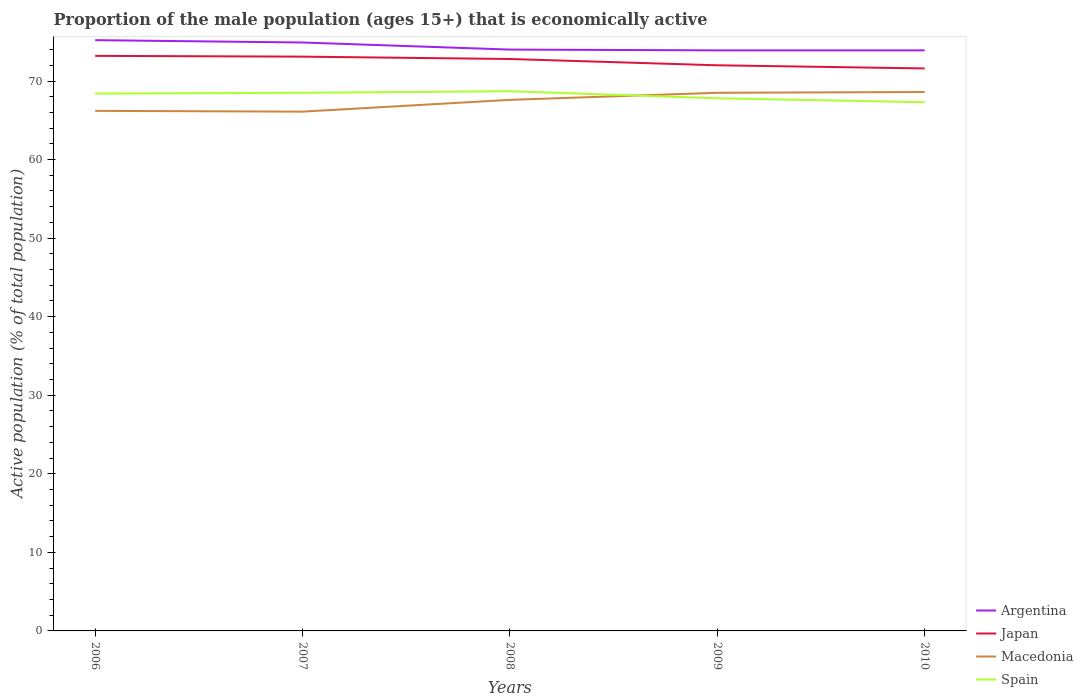Does the line corresponding to Macedonia intersect with the line corresponding to Argentina?
Offer a very short reply. No. Is the number of lines equal to the number of legend labels?
Keep it short and to the point. Yes. Across all years, what is the maximum proportion of the male population that is economically active in Argentina?
Provide a short and direct response. 73.9. In which year was the proportion of the male population that is economically active in Japan maximum?
Provide a succinct answer. 2010. What is the total proportion of the male population that is economically active in Japan in the graph?
Your response must be concise. 0.8. What is the difference between the highest and the second highest proportion of the male population that is economically active in Argentina?
Offer a terse response. 1.3. What is the difference between the highest and the lowest proportion of the male population that is economically active in Spain?
Make the answer very short. 3. How many years are there in the graph?
Provide a succinct answer. 5. Does the graph contain any zero values?
Give a very brief answer. No. What is the title of the graph?
Offer a terse response. Proportion of the male population (ages 15+) that is economically active. Does "Cote d'Ivoire" appear as one of the legend labels in the graph?
Your answer should be very brief. No. What is the label or title of the Y-axis?
Your response must be concise. Active population (% of total population). What is the Active population (% of total population) in Argentina in 2006?
Give a very brief answer. 75.2. What is the Active population (% of total population) of Japan in 2006?
Your response must be concise. 73.2. What is the Active population (% of total population) of Macedonia in 2006?
Offer a very short reply. 66.2. What is the Active population (% of total population) of Spain in 2006?
Your response must be concise. 68.4. What is the Active population (% of total population) of Argentina in 2007?
Ensure brevity in your answer.  74.9. What is the Active population (% of total population) of Japan in 2007?
Ensure brevity in your answer.  73.1. What is the Active population (% of total population) in Macedonia in 2007?
Ensure brevity in your answer.  66.1. What is the Active population (% of total population) of Spain in 2007?
Keep it short and to the point. 68.5. What is the Active population (% of total population) of Japan in 2008?
Provide a succinct answer. 72.8. What is the Active population (% of total population) of Macedonia in 2008?
Keep it short and to the point. 67.6. What is the Active population (% of total population) of Spain in 2008?
Keep it short and to the point. 68.7. What is the Active population (% of total population) in Argentina in 2009?
Give a very brief answer. 73.9. What is the Active population (% of total population) in Macedonia in 2009?
Your answer should be compact. 68.5. What is the Active population (% of total population) of Spain in 2009?
Offer a terse response. 67.8. What is the Active population (% of total population) of Argentina in 2010?
Provide a short and direct response. 73.9. What is the Active population (% of total population) of Japan in 2010?
Your answer should be compact. 71.6. What is the Active population (% of total population) of Macedonia in 2010?
Provide a short and direct response. 68.6. What is the Active population (% of total population) in Spain in 2010?
Keep it short and to the point. 67.3. Across all years, what is the maximum Active population (% of total population) of Argentina?
Provide a succinct answer. 75.2. Across all years, what is the maximum Active population (% of total population) of Japan?
Offer a very short reply. 73.2. Across all years, what is the maximum Active population (% of total population) in Macedonia?
Offer a terse response. 68.6. Across all years, what is the maximum Active population (% of total population) of Spain?
Your answer should be compact. 68.7. Across all years, what is the minimum Active population (% of total population) in Argentina?
Provide a short and direct response. 73.9. Across all years, what is the minimum Active population (% of total population) of Japan?
Your answer should be compact. 71.6. Across all years, what is the minimum Active population (% of total population) in Macedonia?
Provide a succinct answer. 66.1. Across all years, what is the minimum Active population (% of total population) in Spain?
Provide a short and direct response. 67.3. What is the total Active population (% of total population) of Argentina in the graph?
Offer a terse response. 371.9. What is the total Active population (% of total population) of Japan in the graph?
Provide a short and direct response. 362.7. What is the total Active population (% of total population) in Macedonia in the graph?
Give a very brief answer. 337. What is the total Active population (% of total population) of Spain in the graph?
Make the answer very short. 340.7. What is the difference between the Active population (% of total population) of Argentina in 2006 and that in 2007?
Ensure brevity in your answer.  0.3. What is the difference between the Active population (% of total population) of Macedonia in 2006 and that in 2007?
Provide a short and direct response. 0.1. What is the difference between the Active population (% of total population) of Spain in 2006 and that in 2007?
Offer a terse response. -0.1. What is the difference between the Active population (% of total population) of Argentina in 2006 and that in 2008?
Keep it short and to the point. 1.2. What is the difference between the Active population (% of total population) in Japan in 2006 and that in 2008?
Provide a succinct answer. 0.4. What is the difference between the Active population (% of total population) in Macedonia in 2006 and that in 2008?
Keep it short and to the point. -1.4. What is the difference between the Active population (% of total population) in Japan in 2006 and that in 2009?
Provide a succinct answer. 1.2. What is the difference between the Active population (% of total population) of Argentina in 2006 and that in 2010?
Your answer should be very brief. 1.3. What is the difference between the Active population (% of total population) of Macedonia in 2006 and that in 2010?
Provide a short and direct response. -2.4. What is the difference between the Active population (% of total population) in Argentina in 2007 and that in 2008?
Your answer should be very brief. 0.9. What is the difference between the Active population (% of total population) of Macedonia in 2007 and that in 2008?
Your answer should be very brief. -1.5. What is the difference between the Active population (% of total population) of Spain in 2007 and that in 2008?
Ensure brevity in your answer.  -0.2. What is the difference between the Active population (% of total population) of Japan in 2007 and that in 2009?
Keep it short and to the point. 1.1. What is the difference between the Active population (% of total population) of Spain in 2007 and that in 2009?
Offer a very short reply. 0.7. What is the difference between the Active population (% of total population) in Argentina in 2007 and that in 2010?
Offer a very short reply. 1. What is the difference between the Active population (% of total population) of Macedonia in 2007 and that in 2010?
Offer a terse response. -2.5. What is the difference between the Active population (% of total population) of Spain in 2007 and that in 2010?
Make the answer very short. 1.2. What is the difference between the Active population (% of total population) in Spain in 2008 and that in 2009?
Provide a succinct answer. 0.9. What is the difference between the Active population (% of total population) in Argentina in 2008 and that in 2010?
Provide a succinct answer. 0.1. What is the difference between the Active population (% of total population) of Japan in 2008 and that in 2010?
Offer a terse response. 1.2. What is the difference between the Active population (% of total population) in Macedonia in 2008 and that in 2010?
Give a very brief answer. -1. What is the difference between the Active population (% of total population) of Spain in 2008 and that in 2010?
Ensure brevity in your answer.  1.4. What is the difference between the Active population (% of total population) in Argentina in 2009 and that in 2010?
Your response must be concise. 0. What is the difference between the Active population (% of total population) of Macedonia in 2009 and that in 2010?
Keep it short and to the point. -0.1. What is the difference between the Active population (% of total population) in Spain in 2009 and that in 2010?
Provide a short and direct response. 0.5. What is the difference between the Active population (% of total population) in Japan in 2006 and the Active population (% of total population) in Macedonia in 2007?
Give a very brief answer. 7.1. What is the difference between the Active population (% of total population) in Japan in 2006 and the Active population (% of total population) in Spain in 2007?
Make the answer very short. 4.7. What is the difference between the Active population (% of total population) of Argentina in 2006 and the Active population (% of total population) of Spain in 2008?
Your response must be concise. 6.5. What is the difference between the Active population (% of total population) in Japan in 2006 and the Active population (% of total population) in Macedonia in 2008?
Your response must be concise. 5.6. What is the difference between the Active population (% of total population) of Macedonia in 2006 and the Active population (% of total population) of Spain in 2008?
Your answer should be compact. -2.5. What is the difference between the Active population (% of total population) in Argentina in 2006 and the Active population (% of total population) in Macedonia in 2009?
Your answer should be compact. 6.7. What is the difference between the Active population (% of total population) of Japan in 2006 and the Active population (% of total population) of Macedonia in 2009?
Keep it short and to the point. 4.7. What is the difference between the Active population (% of total population) of Japan in 2006 and the Active population (% of total population) of Spain in 2009?
Your response must be concise. 5.4. What is the difference between the Active population (% of total population) of Macedonia in 2006 and the Active population (% of total population) of Spain in 2009?
Offer a terse response. -1.6. What is the difference between the Active population (% of total population) of Argentina in 2006 and the Active population (% of total population) of Japan in 2010?
Give a very brief answer. 3.6. What is the difference between the Active population (% of total population) of Argentina in 2006 and the Active population (% of total population) of Macedonia in 2010?
Offer a terse response. 6.6. What is the difference between the Active population (% of total population) in Argentina in 2006 and the Active population (% of total population) in Spain in 2010?
Offer a terse response. 7.9. What is the difference between the Active population (% of total population) in Japan in 2006 and the Active population (% of total population) in Spain in 2010?
Provide a succinct answer. 5.9. What is the difference between the Active population (% of total population) of Macedonia in 2006 and the Active population (% of total population) of Spain in 2010?
Offer a very short reply. -1.1. What is the difference between the Active population (% of total population) in Japan in 2007 and the Active population (% of total population) in Macedonia in 2008?
Provide a succinct answer. 5.5. What is the difference between the Active population (% of total population) of Japan in 2007 and the Active population (% of total population) of Spain in 2008?
Your answer should be compact. 4.4. What is the difference between the Active population (% of total population) in Argentina in 2007 and the Active population (% of total population) in Spain in 2009?
Offer a terse response. 7.1. What is the difference between the Active population (% of total population) in Japan in 2007 and the Active population (% of total population) in Macedonia in 2009?
Offer a very short reply. 4.6. What is the difference between the Active population (% of total population) of Argentina in 2007 and the Active population (% of total population) of Japan in 2010?
Provide a succinct answer. 3.3. What is the difference between the Active population (% of total population) of Japan in 2007 and the Active population (% of total population) of Macedonia in 2010?
Offer a terse response. 4.5. What is the difference between the Active population (% of total population) of Argentina in 2008 and the Active population (% of total population) of Japan in 2009?
Make the answer very short. 2. What is the difference between the Active population (% of total population) of Japan in 2008 and the Active population (% of total population) of Spain in 2009?
Give a very brief answer. 5. What is the difference between the Active population (% of total population) of Macedonia in 2008 and the Active population (% of total population) of Spain in 2009?
Provide a succinct answer. -0.2. What is the difference between the Active population (% of total population) of Japan in 2008 and the Active population (% of total population) of Macedonia in 2010?
Provide a short and direct response. 4.2. What is the difference between the Active population (% of total population) in Japan in 2008 and the Active population (% of total population) in Spain in 2010?
Make the answer very short. 5.5. What is the difference between the Active population (% of total population) of Macedonia in 2008 and the Active population (% of total population) of Spain in 2010?
Ensure brevity in your answer.  0.3. What is the difference between the Active population (% of total population) of Argentina in 2009 and the Active population (% of total population) of Japan in 2010?
Make the answer very short. 2.3. What is the difference between the Active population (% of total population) in Argentina in 2009 and the Active population (% of total population) in Spain in 2010?
Make the answer very short. 6.6. What is the difference between the Active population (% of total population) in Macedonia in 2009 and the Active population (% of total population) in Spain in 2010?
Keep it short and to the point. 1.2. What is the average Active population (% of total population) in Argentina per year?
Offer a very short reply. 74.38. What is the average Active population (% of total population) of Japan per year?
Ensure brevity in your answer.  72.54. What is the average Active population (% of total population) of Macedonia per year?
Keep it short and to the point. 67.4. What is the average Active population (% of total population) in Spain per year?
Offer a very short reply. 68.14. In the year 2006, what is the difference between the Active population (% of total population) in Japan and Active population (% of total population) in Spain?
Make the answer very short. 4.8. In the year 2006, what is the difference between the Active population (% of total population) of Macedonia and Active population (% of total population) of Spain?
Your answer should be very brief. -2.2. In the year 2007, what is the difference between the Active population (% of total population) in Argentina and Active population (% of total population) in Macedonia?
Ensure brevity in your answer.  8.8. In the year 2007, what is the difference between the Active population (% of total population) in Japan and Active population (% of total population) in Spain?
Provide a short and direct response. 4.6. In the year 2007, what is the difference between the Active population (% of total population) in Macedonia and Active population (% of total population) in Spain?
Your answer should be very brief. -2.4. In the year 2008, what is the difference between the Active population (% of total population) of Argentina and Active population (% of total population) of Macedonia?
Your answer should be compact. 6.4. In the year 2008, what is the difference between the Active population (% of total population) in Japan and Active population (% of total population) in Macedonia?
Offer a terse response. 5.2. In the year 2008, what is the difference between the Active population (% of total population) of Macedonia and Active population (% of total population) of Spain?
Make the answer very short. -1.1. In the year 2009, what is the difference between the Active population (% of total population) in Argentina and Active population (% of total population) in Macedonia?
Offer a terse response. 5.4. In the year 2009, what is the difference between the Active population (% of total population) of Argentina and Active population (% of total population) of Spain?
Make the answer very short. 6.1. In the year 2009, what is the difference between the Active population (% of total population) in Japan and Active population (% of total population) in Spain?
Make the answer very short. 4.2. In the year 2009, what is the difference between the Active population (% of total population) of Macedonia and Active population (% of total population) of Spain?
Offer a very short reply. 0.7. In the year 2010, what is the difference between the Active population (% of total population) of Argentina and Active population (% of total population) of Spain?
Offer a terse response. 6.6. In the year 2010, what is the difference between the Active population (% of total population) of Japan and Active population (% of total population) of Macedonia?
Offer a very short reply. 3. In the year 2010, what is the difference between the Active population (% of total population) in Japan and Active population (% of total population) in Spain?
Make the answer very short. 4.3. What is the ratio of the Active population (% of total population) in Argentina in 2006 to that in 2007?
Provide a short and direct response. 1. What is the ratio of the Active population (% of total population) in Macedonia in 2006 to that in 2007?
Your response must be concise. 1. What is the ratio of the Active population (% of total population) in Argentina in 2006 to that in 2008?
Your answer should be compact. 1.02. What is the ratio of the Active population (% of total population) in Macedonia in 2006 to that in 2008?
Give a very brief answer. 0.98. What is the ratio of the Active population (% of total population) of Argentina in 2006 to that in 2009?
Keep it short and to the point. 1.02. What is the ratio of the Active population (% of total population) in Japan in 2006 to that in 2009?
Offer a very short reply. 1.02. What is the ratio of the Active population (% of total population) of Macedonia in 2006 to that in 2009?
Ensure brevity in your answer.  0.97. What is the ratio of the Active population (% of total population) in Spain in 2006 to that in 2009?
Provide a succinct answer. 1.01. What is the ratio of the Active population (% of total population) in Argentina in 2006 to that in 2010?
Make the answer very short. 1.02. What is the ratio of the Active population (% of total population) in Japan in 2006 to that in 2010?
Your answer should be very brief. 1.02. What is the ratio of the Active population (% of total population) of Spain in 2006 to that in 2010?
Provide a short and direct response. 1.02. What is the ratio of the Active population (% of total population) in Argentina in 2007 to that in 2008?
Your answer should be very brief. 1.01. What is the ratio of the Active population (% of total population) of Macedonia in 2007 to that in 2008?
Provide a short and direct response. 0.98. What is the ratio of the Active population (% of total population) in Spain in 2007 to that in 2008?
Provide a succinct answer. 1. What is the ratio of the Active population (% of total population) in Argentina in 2007 to that in 2009?
Give a very brief answer. 1.01. What is the ratio of the Active population (% of total population) of Japan in 2007 to that in 2009?
Offer a very short reply. 1.02. What is the ratio of the Active population (% of total population) of Spain in 2007 to that in 2009?
Provide a short and direct response. 1.01. What is the ratio of the Active population (% of total population) of Argentina in 2007 to that in 2010?
Ensure brevity in your answer.  1.01. What is the ratio of the Active population (% of total population) in Japan in 2007 to that in 2010?
Give a very brief answer. 1.02. What is the ratio of the Active population (% of total population) in Macedonia in 2007 to that in 2010?
Your response must be concise. 0.96. What is the ratio of the Active population (% of total population) of Spain in 2007 to that in 2010?
Your answer should be very brief. 1.02. What is the ratio of the Active population (% of total population) of Japan in 2008 to that in 2009?
Ensure brevity in your answer.  1.01. What is the ratio of the Active population (% of total population) in Macedonia in 2008 to that in 2009?
Provide a succinct answer. 0.99. What is the ratio of the Active population (% of total population) of Spain in 2008 to that in 2009?
Make the answer very short. 1.01. What is the ratio of the Active population (% of total population) in Japan in 2008 to that in 2010?
Make the answer very short. 1.02. What is the ratio of the Active population (% of total population) in Macedonia in 2008 to that in 2010?
Offer a very short reply. 0.99. What is the ratio of the Active population (% of total population) of Spain in 2008 to that in 2010?
Ensure brevity in your answer.  1.02. What is the ratio of the Active population (% of total population) in Japan in 2009 to that in 2010?
Give a very brief answer. 1.01. What is the ratio of the Active population (% of total population) in Spain in 2009 to that in 2010?
Your response must be concise. 1.01. What is the difference between the highest and the lowest Active population (% of total population) of Japan?
Give a very brief answer. 1.6. 